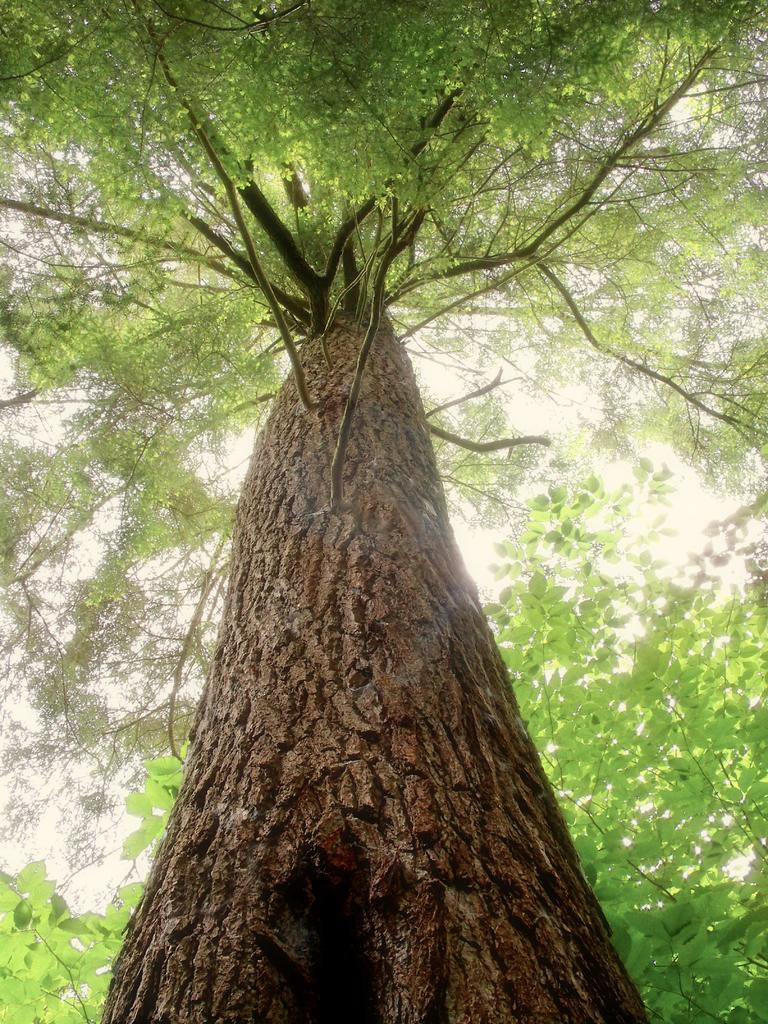What type of vegetation can be seen in the image? There are trees in the image. Where are the majority of leaves located in the image? There are many leaves on the left side of the image. What can be seen in the background of the image? The sky is visible in the background of the image. What type of shock can be seen in the image? There is no shock present in the image; it features trees and leaves. How many bags are visible in the image? There are no bags present in the image. 